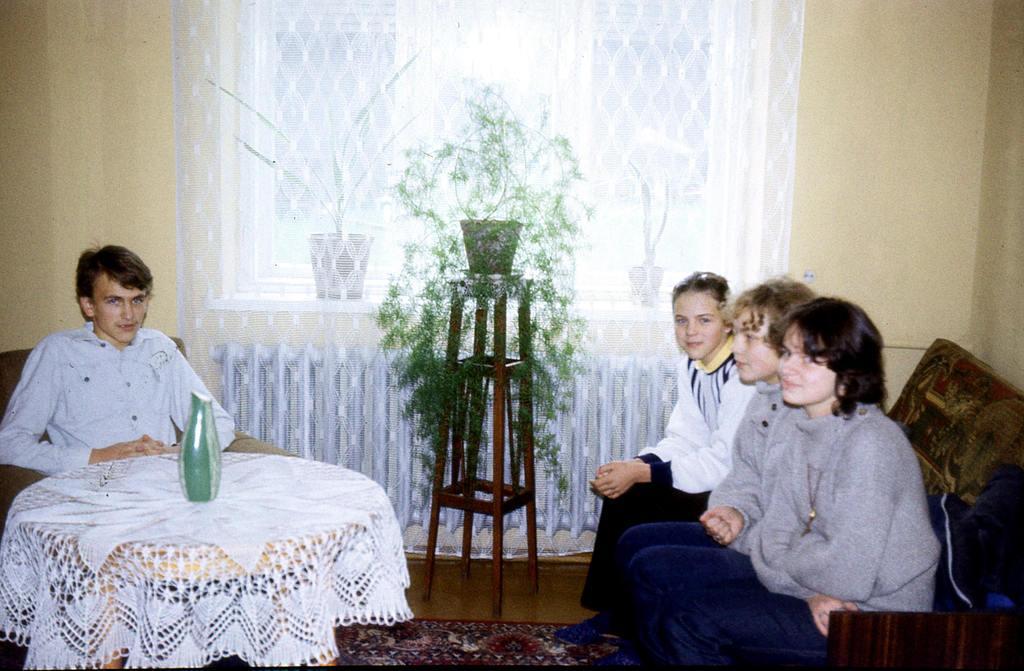How would you summarize this image in a sentence or two? In this picture we have 3 persons sitting in the couch, an another person sitting in the chair near the table in the back ground we have plant , pot , table , curtain , and a carpet. 